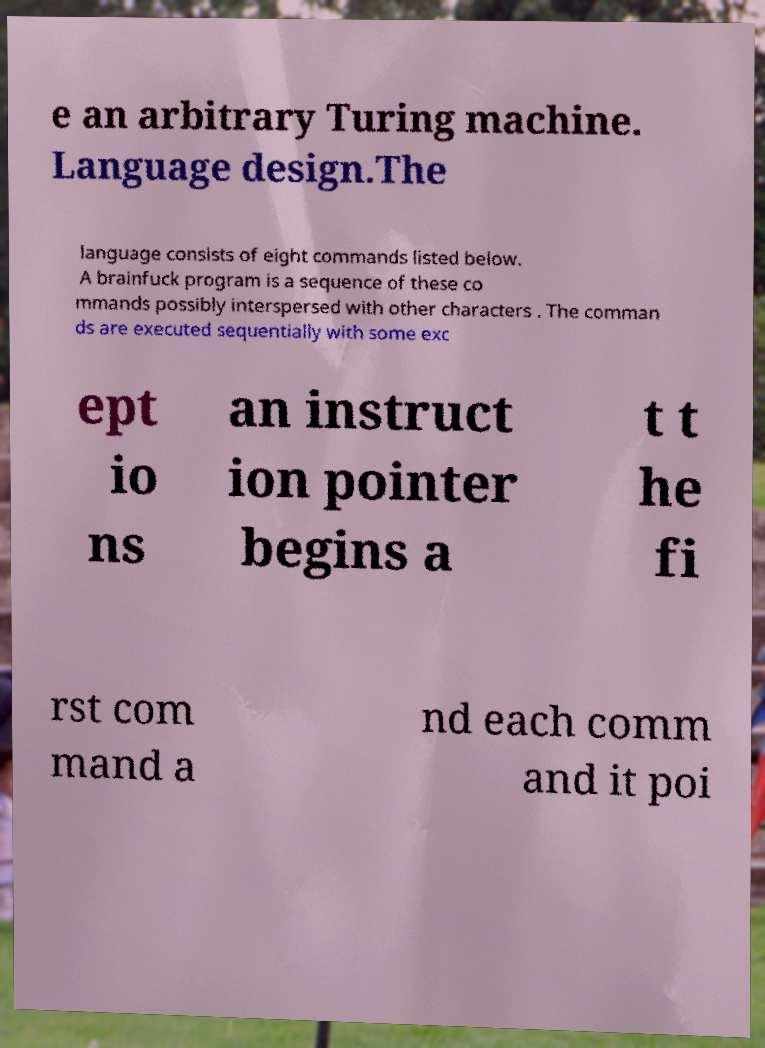Can you read and provide the text displayed in the image?This photo seems to have some interesting text. Can you extract and type it out for me? e an arbitrary Turing machine. Language design.The language consists of eight commands listed below. A brainfuck program is a sequence of these co mmands possibly interspersed with other characters . The comman ds are executed sequentially with some exc ept io ns an instruct ion pointer begins a t t he fi rst com mand a nd each comm and it poi 